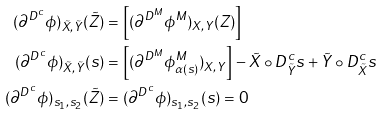<formula> <loc_0><loc_0><loc_500><loc_500>( \partial ^ { D ^ { c } } \phi ) _ { \tilde { X } , \tilde { Y } } ( \tilde { Z } ) & = \left [ ( \partial ^ { D ^ { M } } \phi ^ { M } ) _ { X , Y } ( Z ) \right ] ^ { } \\ ( \partial ^ { D ^ { c } } \phi ) _ { \tilde { X } , \tilde { Y } } ( s ) & = \left [ ( \partial ^ { D ^ { M } } \phi ^ { M } _ { \alpha ( s ) } ) _ { X , Y } \right ] ^ { } - \tilde { X } \circ D ^ { c } _ { \tilde { Y } } s + \tilde { Y } \circ D ^ { c } _ { \tilde { X } } s \\ ( \partial ^ { D ^ { c } } \phi ) _ { s _ { 1 } , s _ { 2 } } ( \tilde { Z } ) & = ( \partial ^ { D ^ { c } } \phi ) _ { s _ { 1 } , s _ { 2 } } ( s ) = 0</formula> 